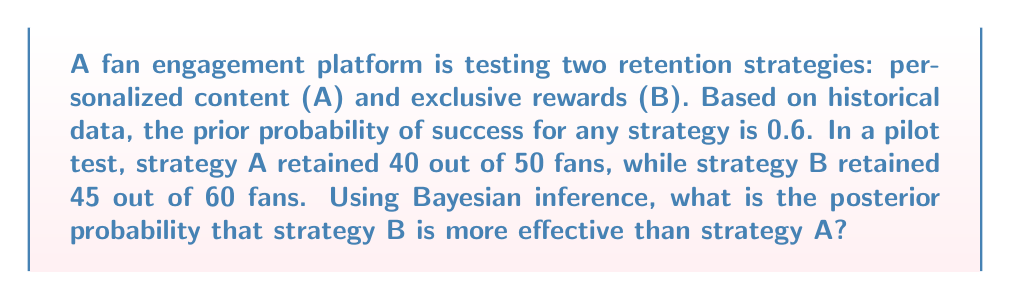What is the answer to this math problem? Let's approach this step-by-step using Bayesian inference:

1) Define our events:
   $H$: Strategy B is more effective than Strategy A
   $D$: Observed data (40/50 for A, 45/60 for B)

2) We want to calculate $P(H|D)$, the posterior probability.

3) Bayes' theorem states:

   $$P(H|D) = \frac{P(D|H)P(H)}{P(D)}$$

4) Calculate $P(H)$, the prior probability:
   Given the prior success probability of 0.6 for any strategy, the probability of B being better than A is 0.5.
   $P(H) = 0.5$

5) Calculate $P(D|H)$, the likelihood:
   We need to calculate the probability of observing the data given that B is better than A.
   We can use the binomial distribution for this:

   $$P(D|H) = \binom{50}{40}(0.6)^{40}(0.4)^{10} \cdot \binom{60}{45}(0.7)^{45}(0.3)^{15}$$

   Here, we assume B has a higher success rate (0.7) than A (0.6).

6) Calculate $P(D|\neg H)$, the probability of the data given that B is not better than A:

   $$P(D|\neg H) = \binom{50}{40}(0.7)^{40}(0.3)^{10} \cdot \binom{60}{45}(0.6)^{45}(0.4)^{15}$$

7) Calculate $P(D)$:
   $P(D) = P(D|H)P(H) + P(D|\neg H)P(\neg H)$

8) Now we can calculate the posterior probability:

   $$P(H|D) = \frac{P(D|H)P(H)}{P(D|H)P(H) + P(D|\neg H)P(\neg H)}$$

9) Plugging in the values and calculating:

   $$P(H|D) \approx 0.8326$$
Answer: 0.8326 